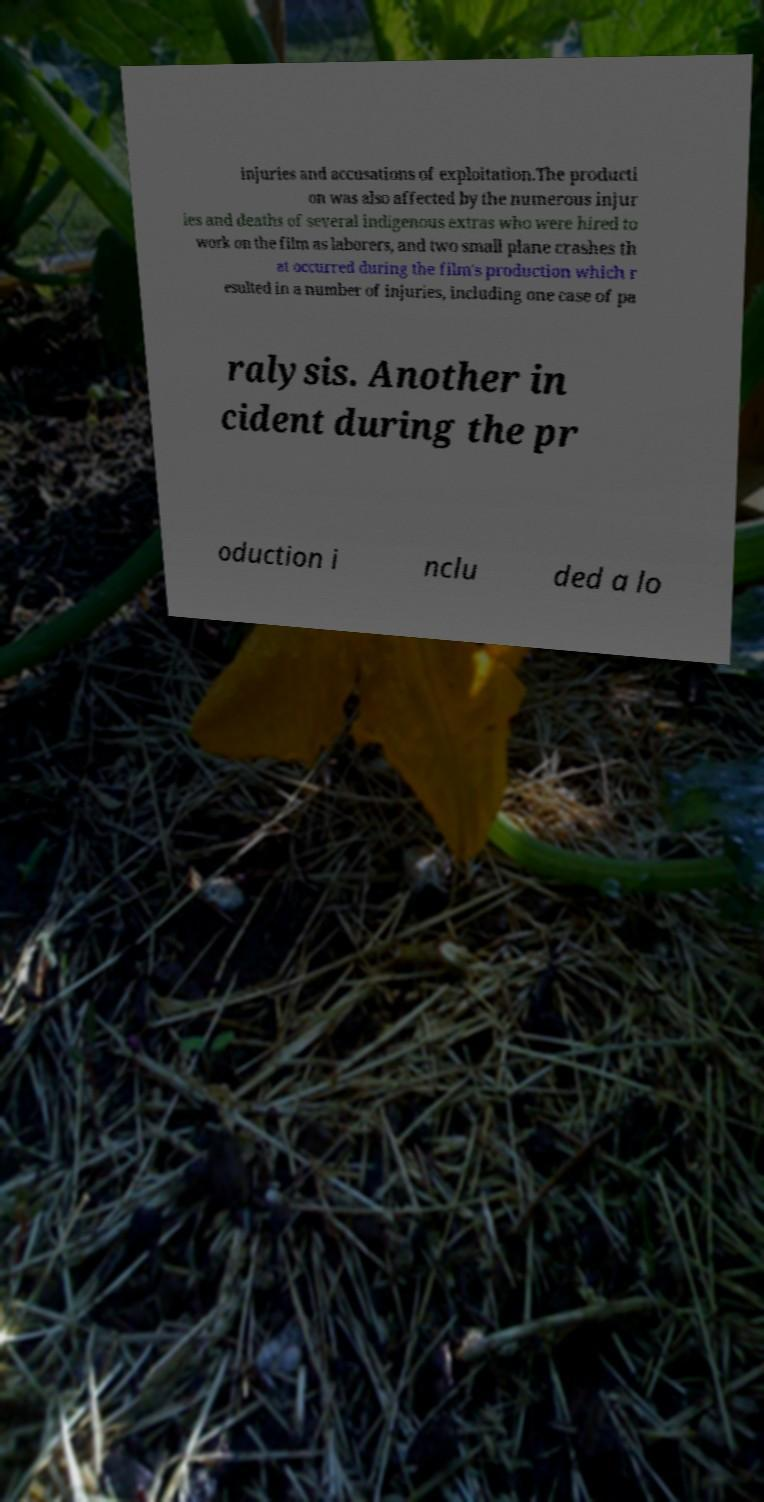Please read and relay the text visible in this image. What does it say? injuries and accusations of exploitation.The producti on was also affected by the numerous injur ies and deaths of several indigenous extras who were hired to work on the film as laborers, and two small plane crashes th at occurred during the film's production which r esulted in a number of injuries, including one case of pa ralysis. Another in cident during the pr oduction i nclu ded a lo 